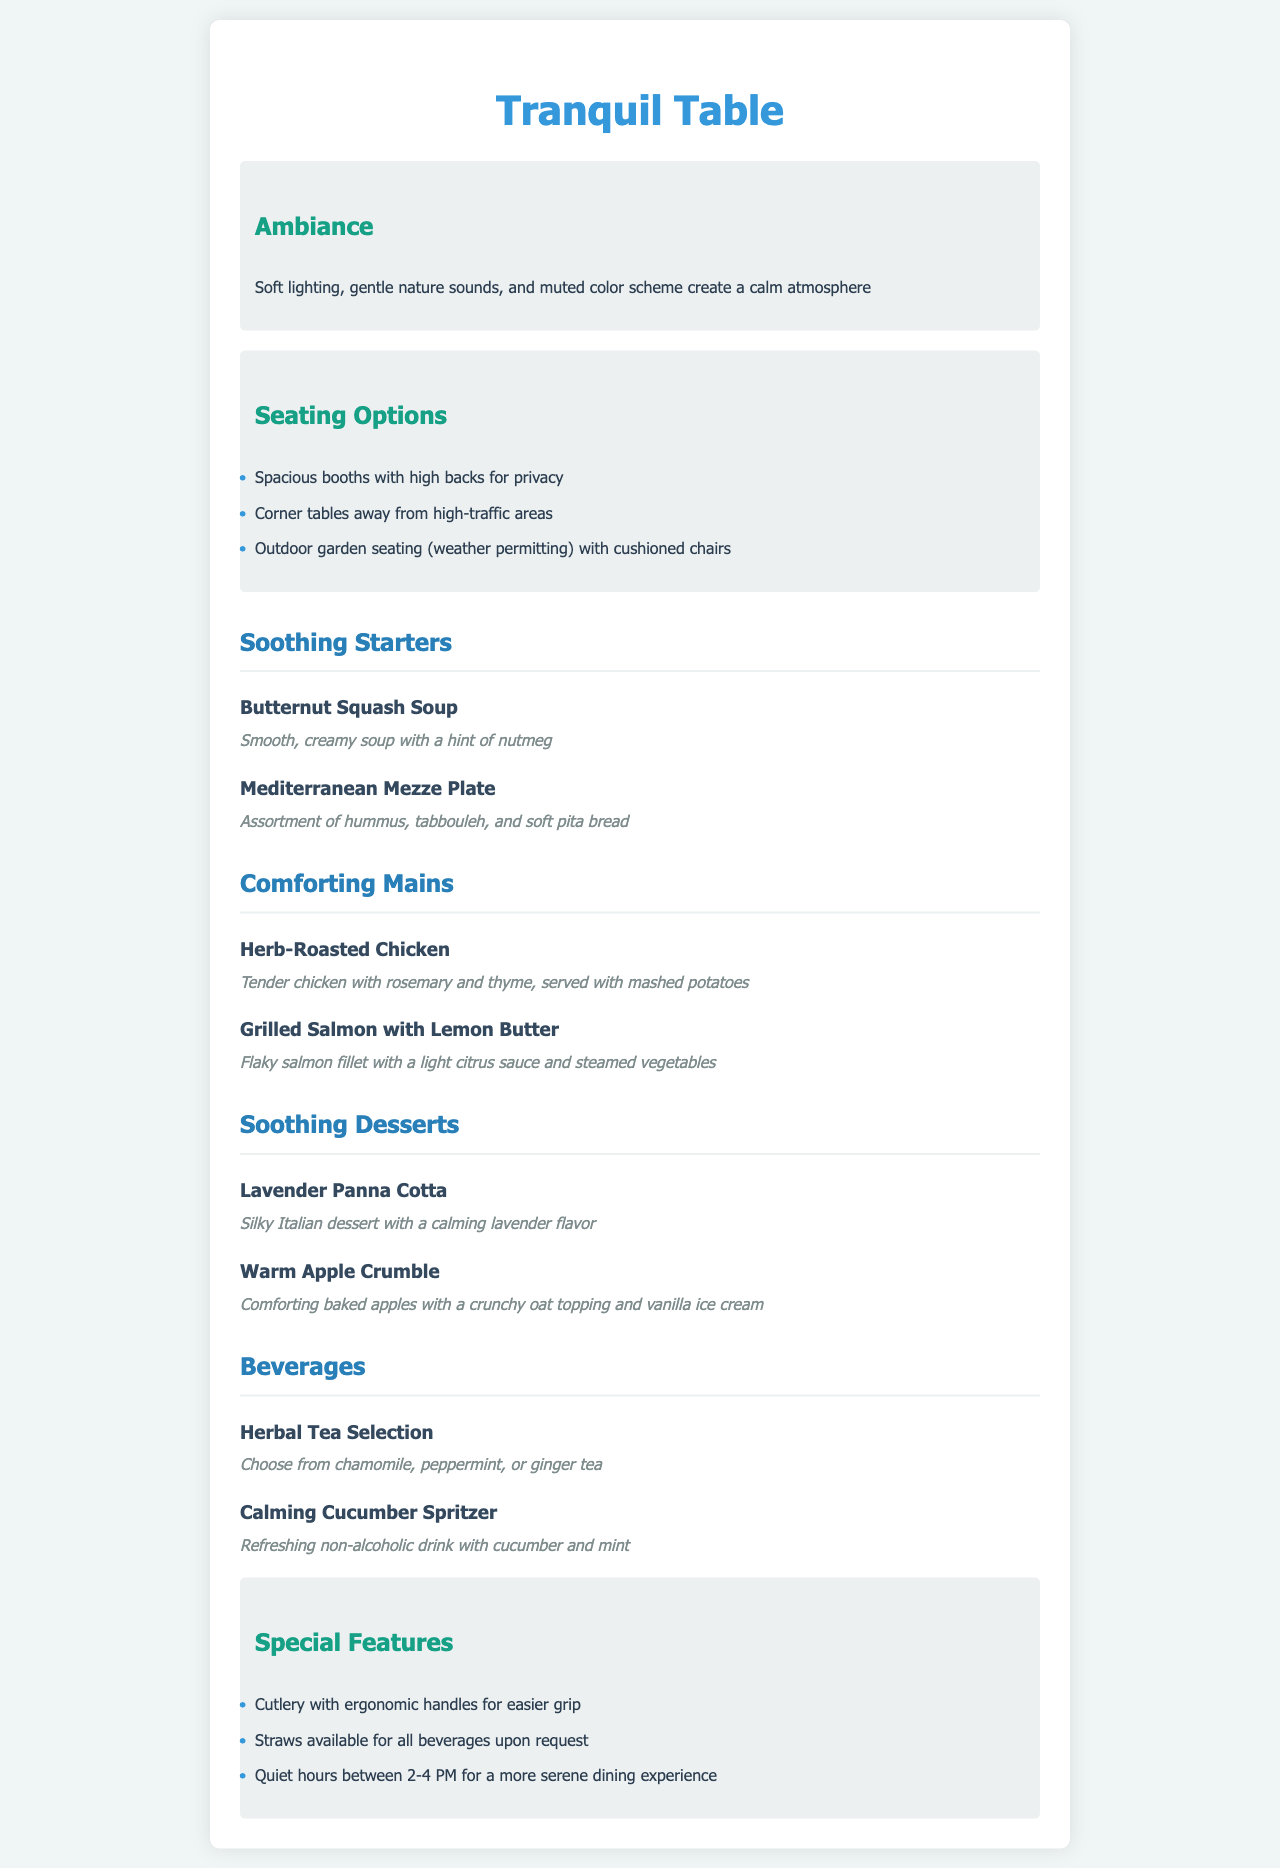What is the name of the restaurant? The name of the restaurant is prominently featured at the top of the document.
Answer: Tranquil Table What type of atmosphere is created in the restaurant? The ambiance description explains the characteristics of the atmosphere.
Answer: Calm atmosphere What is a soothing starter option on the menu? The section lists specific dishes that fall under the starters category.
Answer: Butternut Squash Soup What is a comforting main dish available? The menu item listed under mains describes options for main courses.
Answer: Herb-Roasted Chicken How many seating options are mentioned? The seating options section includes a list that can be counted.
Answer: Three What is one of the special features offered? The special features section lists specific accommodations available for diners.
Answer: Cutlery with ergonomic handles During what hours are the quiet hours scheduled? The special features section specifies the timing for quiet hours.
Answer: 2-4 PM What type of beverage is available? The beverages section lists different drink options available to customers.
Answer: Herbal Tea Selection What kind of dessert is listed that includes lavender? The desserts section specifies a particular dessert that features lavender.
Answer: Lavender Panna Cotta 